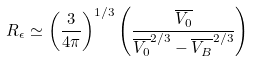Convert formula to latex. <formula><loc_0><loc_0><loc_500><loc_500>R _ { \epsilon } \simeq \left ( \frac { 3 } { 4 { \pi } } \right ) ^ { 1 / 3 } \left ( \frac { \overline { V _ { 0 } } } { \overline { V _ { 0 } } ^ { 2 / 3 } - \overline { V _ { B } } ^ { 2 / 3 } } \right )</formula> 